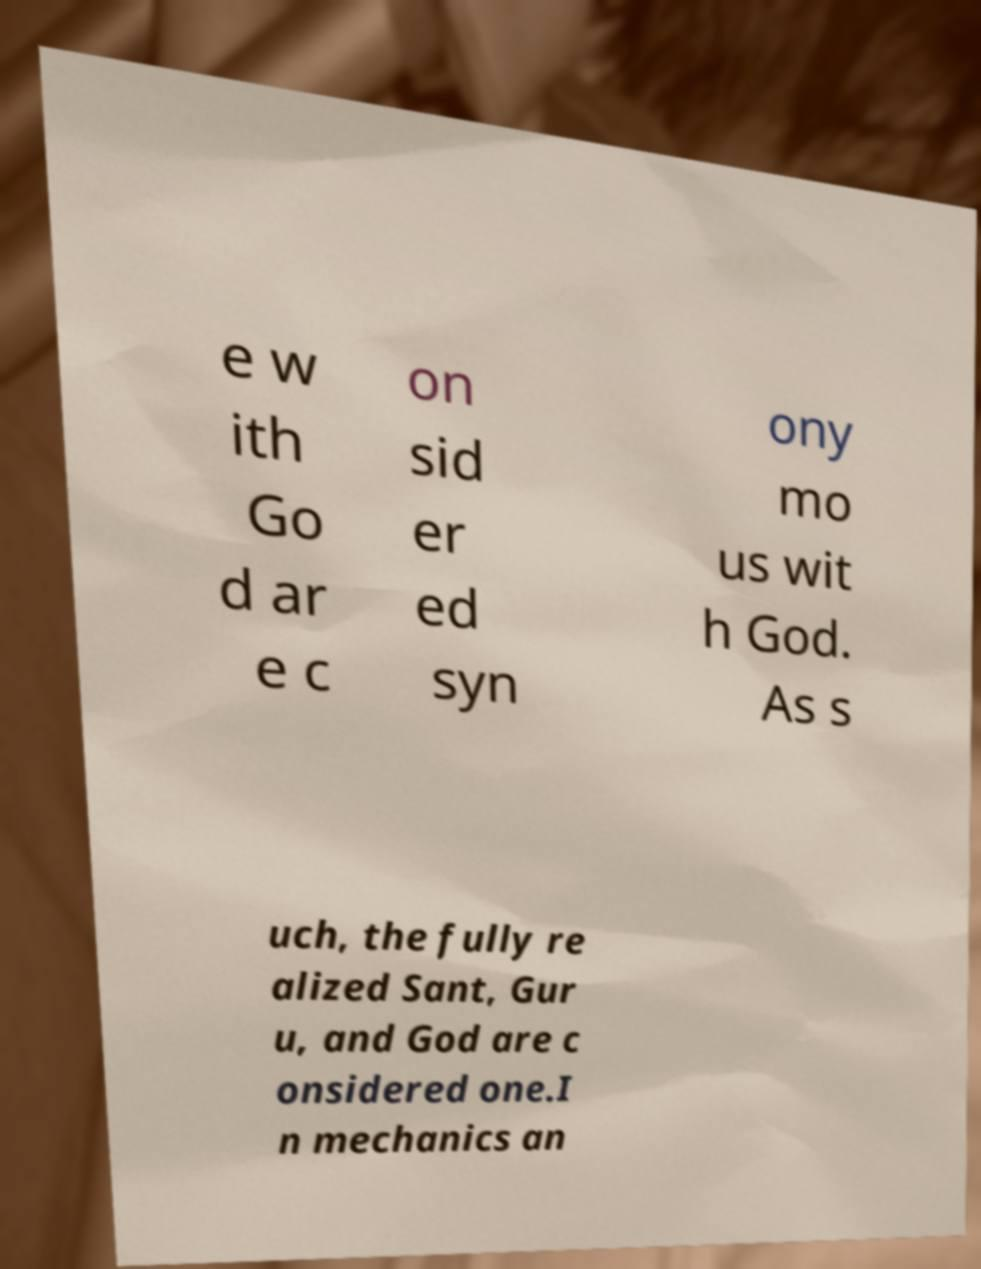Please identify and transcribe the text found in this image. e w ith Go d ar e c on sid er ed syn ony mo us wit h God. As s uch, the fully re alized Sant, Gur u, and God are c onsidered one.I n mechanics an 